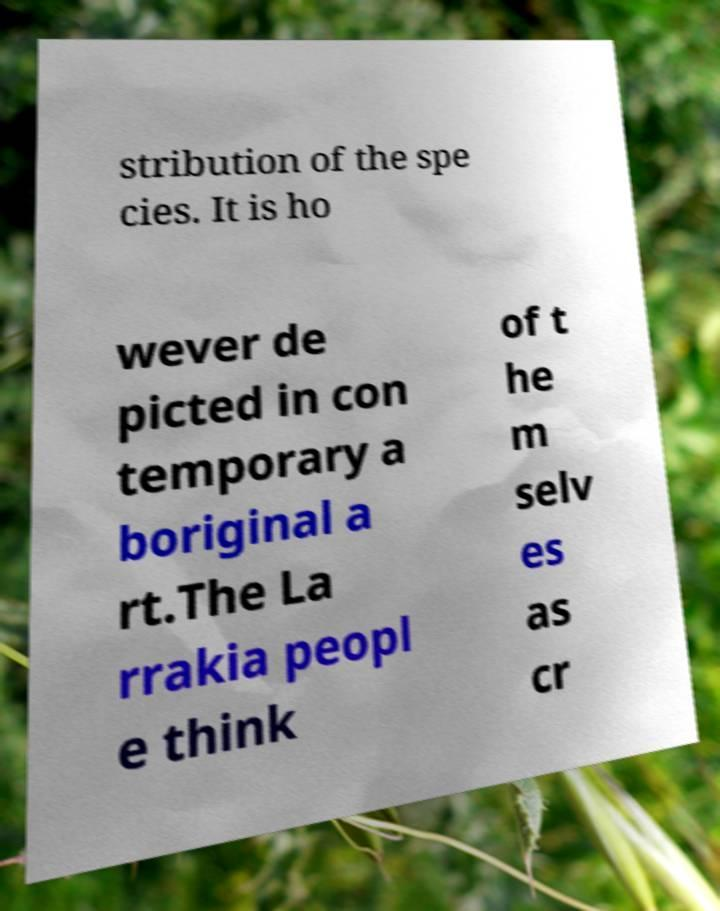What messages or text are displayed in this image? I need them in a readable, typed format. stribution of the spe cies. It is ho wever de picted in con temporary a boriginal a rt.The La rrakia peopl e think of t he m selv es as cr 